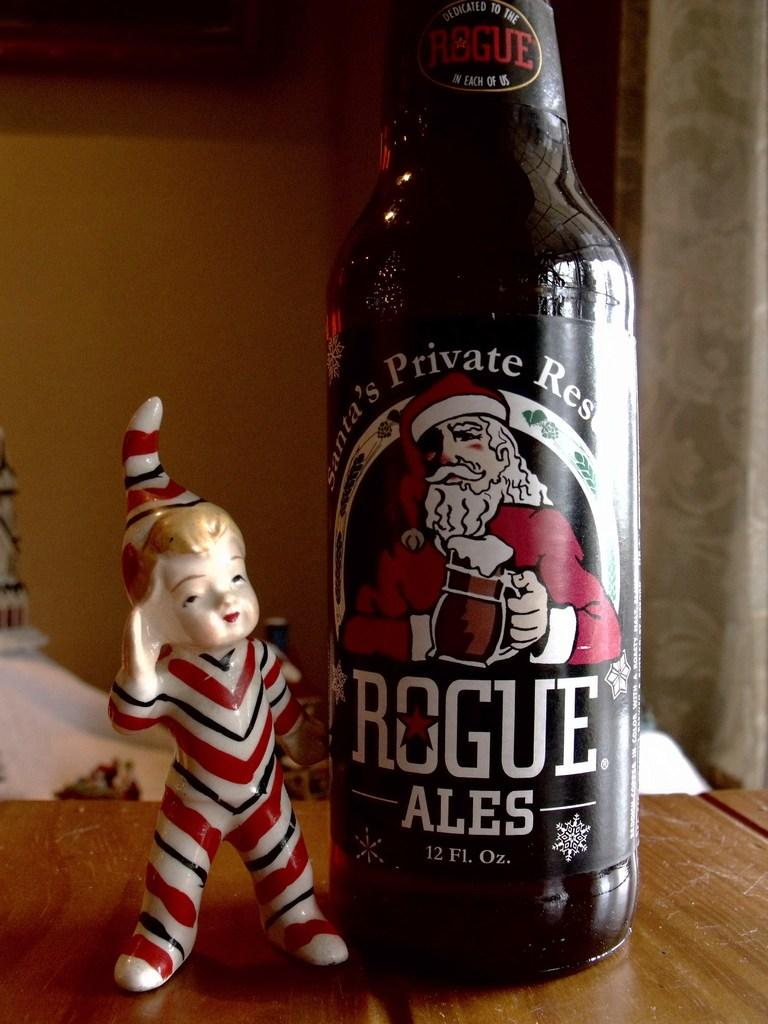Provide a one-sentence caption for the provided image. A bottle of beer that has a santa clause on it called Rogue Ales and has an elf statue next to it. 